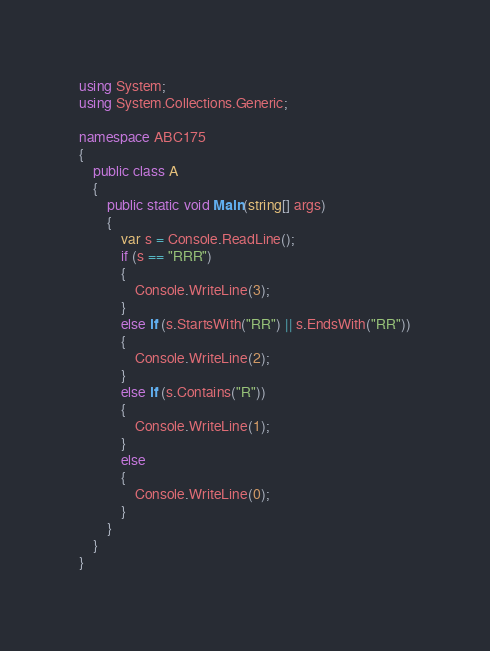<code> <loc_0><loc_0><loc_500><loc_500><_C#_>using System;
using System.Collections.Generic;

namespace ABC175
{
    public class A
    {
        public static void Main(string[] args)
        {
            var s = Console.ReadLine();
            if (s == "RRR")
            {
                Console.WriteLine(3);
            }
            else if (s.StartsWith("RR") || s.EndsWith("RR"))
            {
                Console.WriteLine(2);
            }
            else if (s.Contains("R"))
            {
                Console.WriteLine(1);
            }
            else
            {
                Console.WriteLine(0);
            }
        }
    }
}</code> 